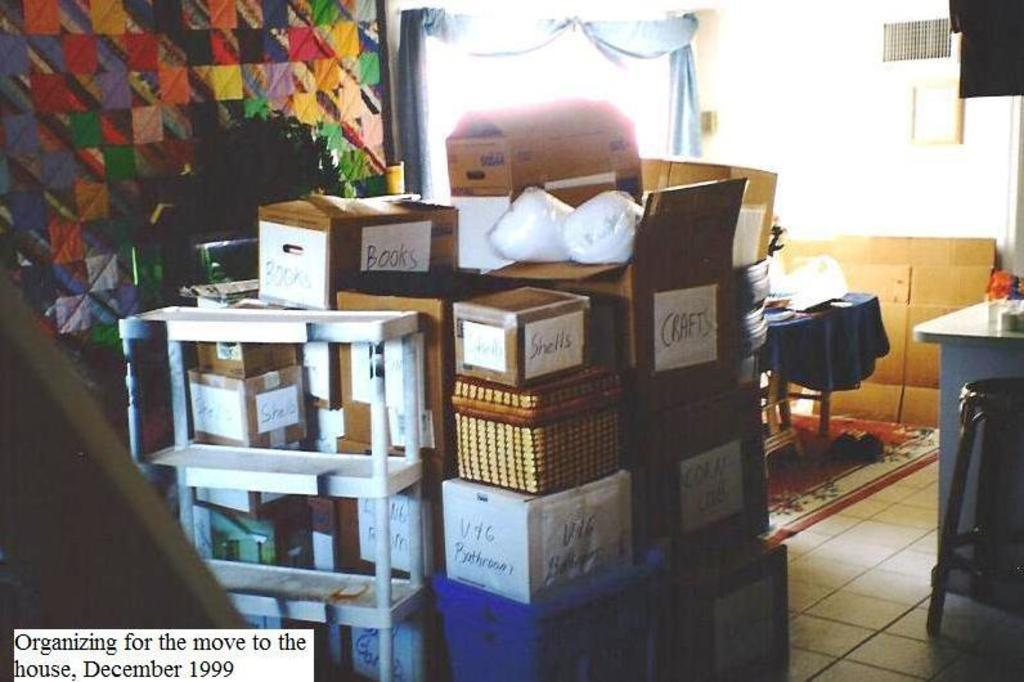What type of objects have writing on them in the image? There are boxes with writing on them in the image. Where are the boxes located in relation to other objects? The boxes are placed beside a white stand. Can you describe any other objects visible in the background? There are other objects in the background, but their specific details are not mentioned in the provided facts. What type of liquid is being poured from the box in the image? There is no liquid being poured from the box in the image; it is a stationary object with writing on it. Can you see a cat playing with the boxes in the image? There is no cat present in the image; it only features boxes with writing on them and a white stand. 